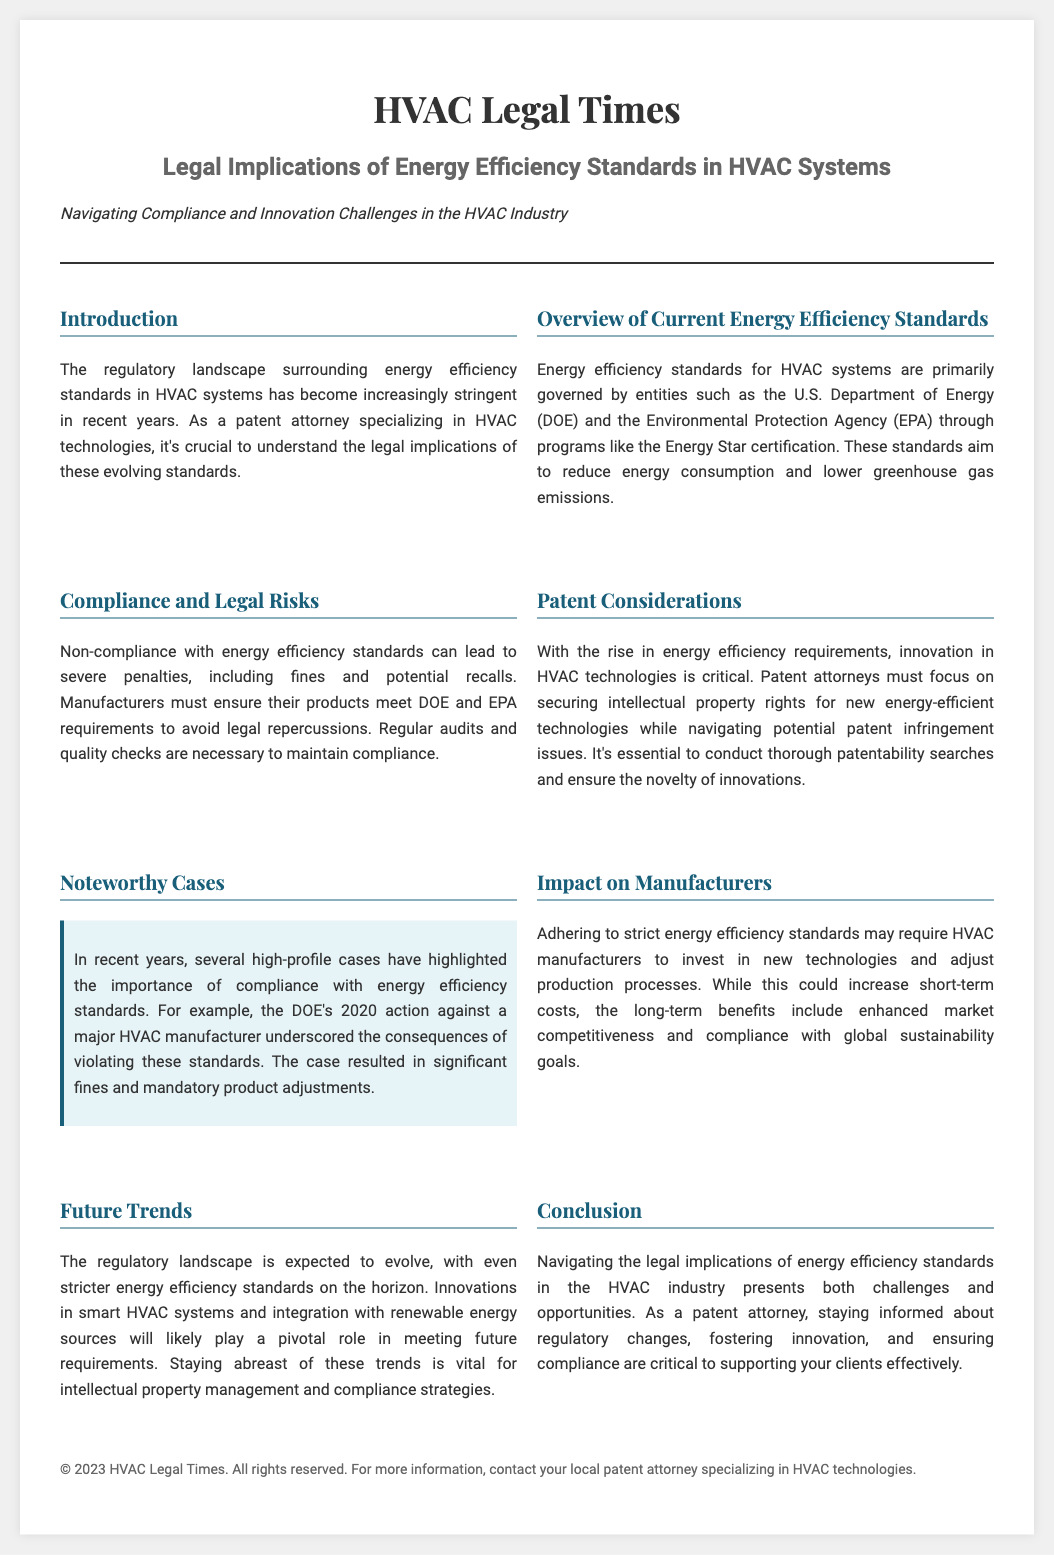What is the title of the article? The title of the article is stated at the top of the document.
Answer: HVAC Legal Times Who governs energy efficiency standards for HVAC systems? The governing entities for energy efficiency standards mentioned in the document are identified clearly.
Answer: U.S. Department of Energy and Environmental Protection Agency What is one potential consequence of non-compliance? The document specifies several legal repercussions for non-compliance.
Answer: Fines What must patent attorneys conduct to ensure novelty? The document mentions a specific action that patent attorneys must take regarding patent rights.
Answer: Patentability searches What happened in the DOE's action against a major HVAC manufacturer? A high-profile case is described, highlighting its significance.
Answer: Significant fines What is a future trend mentioned in the document? The conclusion discusses anticipated changes in the HVAC industry’s regulatory landscape.
Answer: Stricter energy efficiency standards What type of systems are expected to innovate? This is mentioned in the section discussing future trends and regulatory evolution.
Answer: Smart HVAC systems What does the document emphasize as critical for patent attorneys? The conclusion points out an important aspect for patent attorneys in managing compliance.
Answer: Staying informed about regulatory changes 